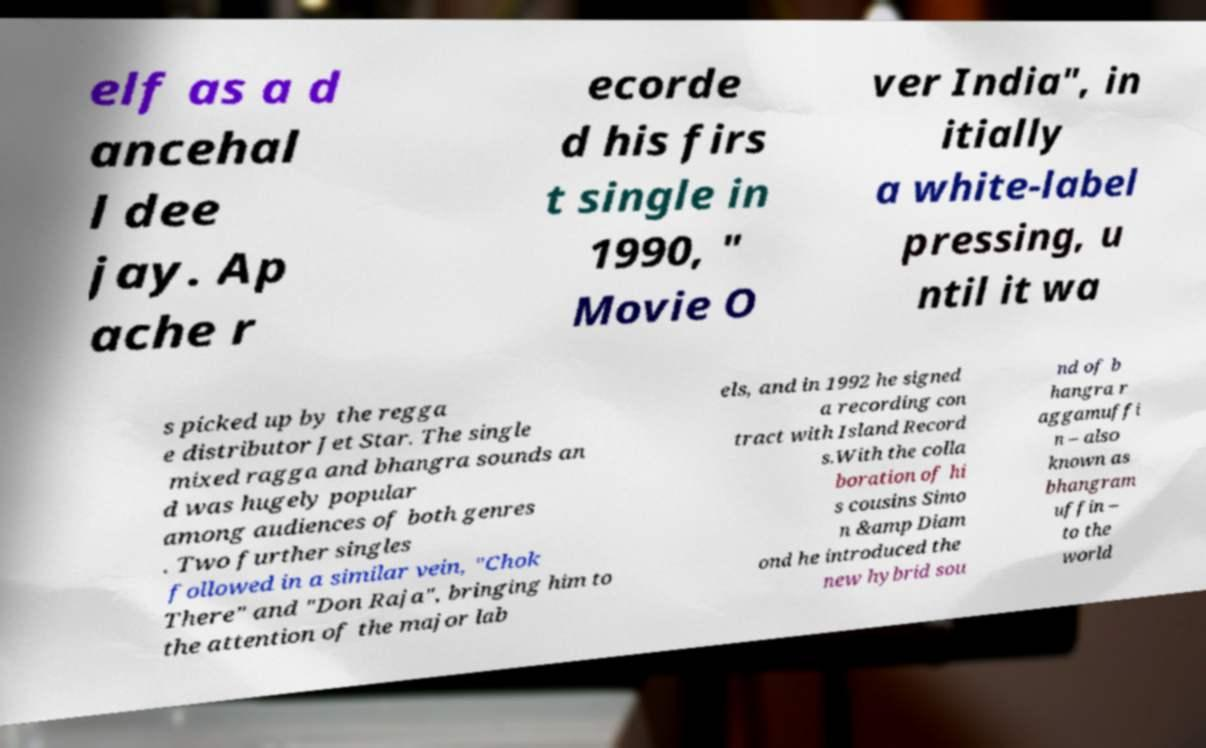Please identify and transcribe the text found in this image. elf as a d ancehal l dee jay. Ap ache r ecorde d his firs t single in 1990, " Movie O ver India", in itially a white-label pressing, u ntil it wa s picked up by the regga e distributor Jet Star. The single mixed ragga and bhangra sounds an d was hugely popular among audiences of both genres . Two further singles followed in a similar vein, "Chok There" and "Don Raja", bringing him to the attention of the major lab els, and in 1992 he signed a recording con tract with Island Record s.With the colla boration of hi s cousins Simo n &amp Diam ond he introduced the new hybrid sou nd of b hangra r aggamuffi n – also known as bhangram uffin – to the world 